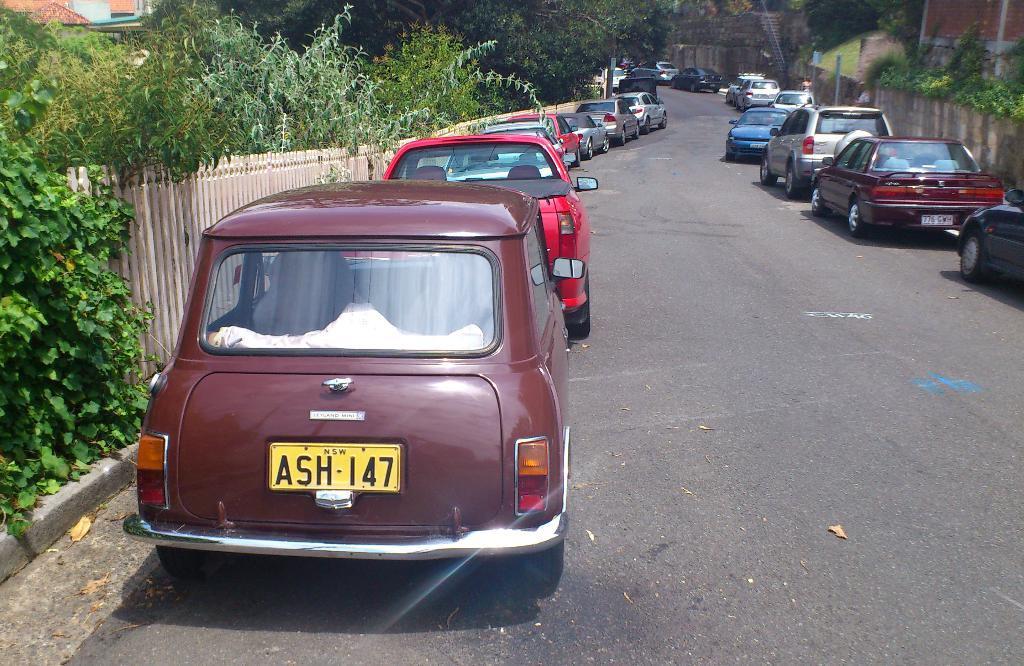In one or two sentences, can you explain what this image depicts? In this image there are vehicles, railing, buildings, trees, plants, road, people, pole and objects. Vehicles are on the road. 